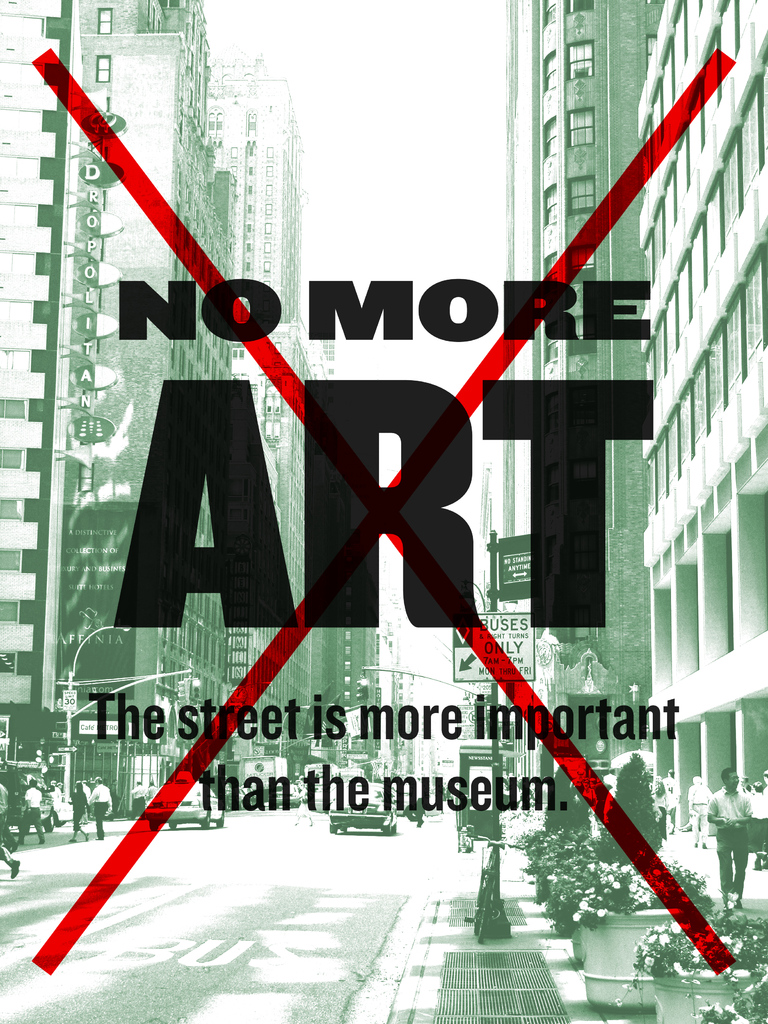How might this image challenge traditional views of art? This image challenges traditional views by questioning the necessity and relevance of museums as the primary venues for art. The juxtaposition of the protest slogan with the everyday street scene suggests that art should be an accessible, integral part of daily life rather than secluded spaces like museums. It questions the elitism and exclusivity often associated with the art world and encourages a democratization of art, making it a more inclusive experience. 